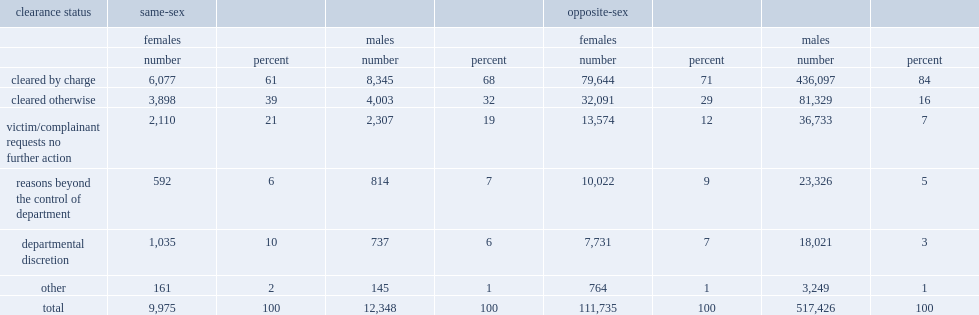On average, over the nine-year period, what are the percentages for same-sex ipv incidents and opposite-sex incidents, involving male partners resulted in the laying of or recommendation for a charge? 68.0 84.0. 61% of females accused in same-sex incidents were charged or recommended for a charge, compared to 71% of females in opposite-sex partnerships. 61.0 71.0. What are percentages for police-reported same-sex ipv incidents involving males, and involving females, the victims requested that no further action be taken against their partners? 19.0 21.0. What pecentages of opposite-sex ipv incidents involving males and females accused requested no further action, respectively? 7.0 12.0. 